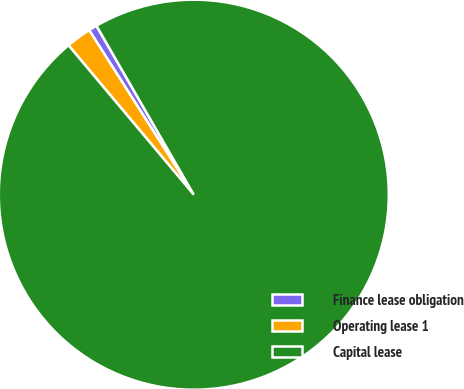<chart> <loc_0><loc_0><loc_500><loc_500><pie_chart><fcel>Finance lease obligation<fcel>Operating lease 1<fcel>Capital lease<nl><fcel>0.7%<fcel>2.09%<fcel>97.21%<nl></chart> 